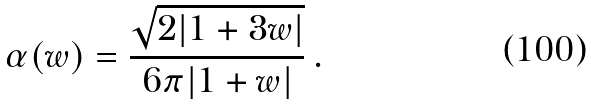<formula> <loc_0><loc_0><loc_500><loc_500>\alpha ( w ) = \frac { \sqrt { 2 | 1 + 3 w | } } { 6 \pi | 1 + w | } \, .</formula> 